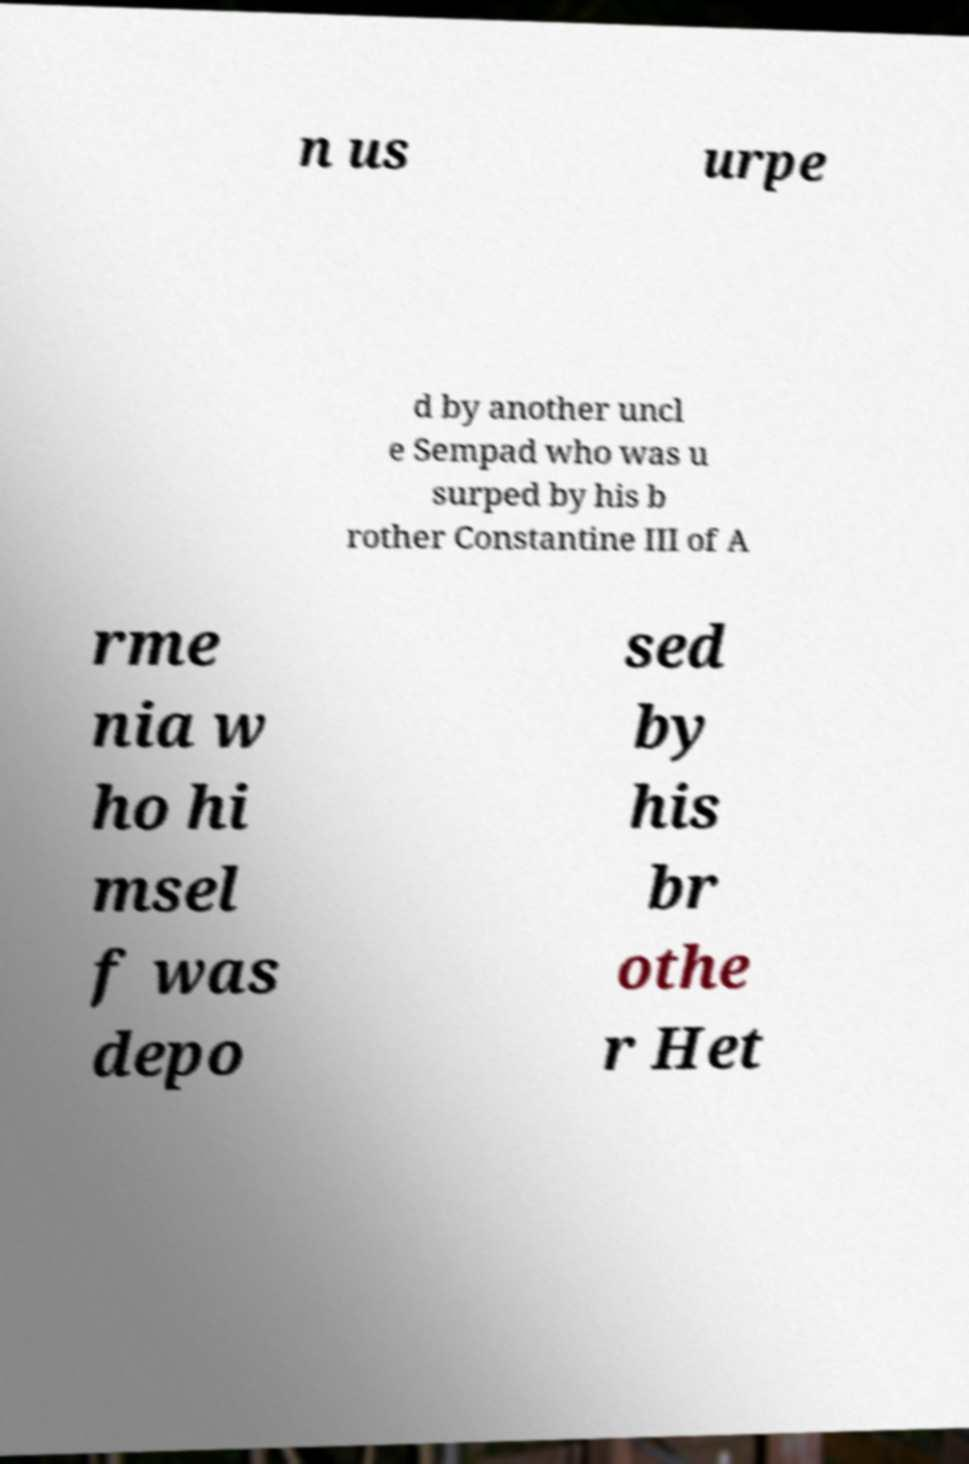Can you read and provide the text displayed in the image?This photo seems to have some interesting text. Can you extract and type it out for me? n us urpe d by another uncl e Sempad who was u surped by his b rother Constantine III of A rme nia w ho hi msel f was depo sed by his br othe r Het 